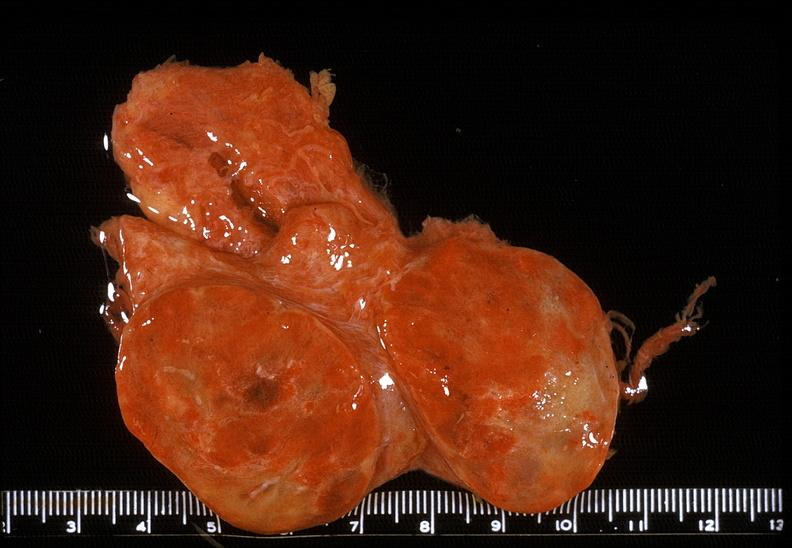where does this belong to?
Answer the question using a single word or phrase. Endocrine system 